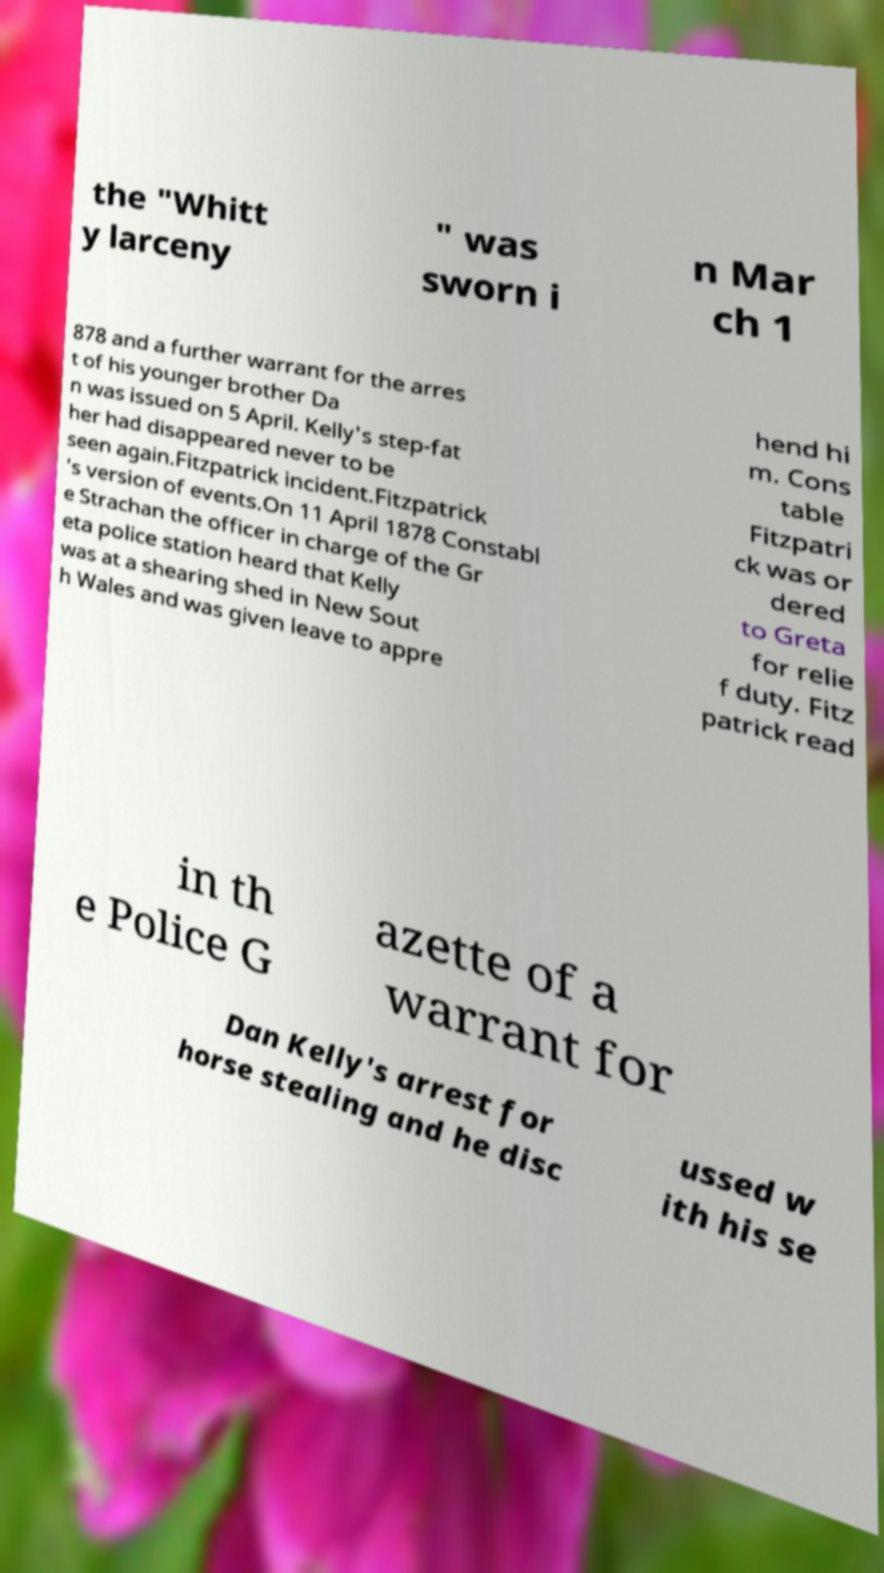Can you read and provide the text displayed in the image?This photo seems to have some interesting text. Can you extract and type it out for me? the "Whitt y larceny " was sworn i n Mar ch 1 878 and a further warrant for the arres t of his younger brother Da n was issued on 5 April. Kelly's step-fat her had disappeared never to be seen again.Fitzpatrick incident.Fitzpatrick 's version of events.On 11 April 1878 Constabl e Strachan the officer in charge of the Gr eta police station heard that Kelly was at a shearing shed in New Sout h Wales and was given leave to appre hend hi m. Cons table Fitzpatri ck was or dered to Greta for relie f duty. Fitz patrick read in th e Police G azette of a warrant for Dan Kelly's arrest for horse stealing and he disc ussed w ith his se 